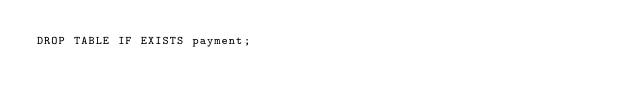<code> <loc_0><loc_0><loc_500><loc_500><_SQL_>DROP TABLE IF EXISTS payment;</code> 